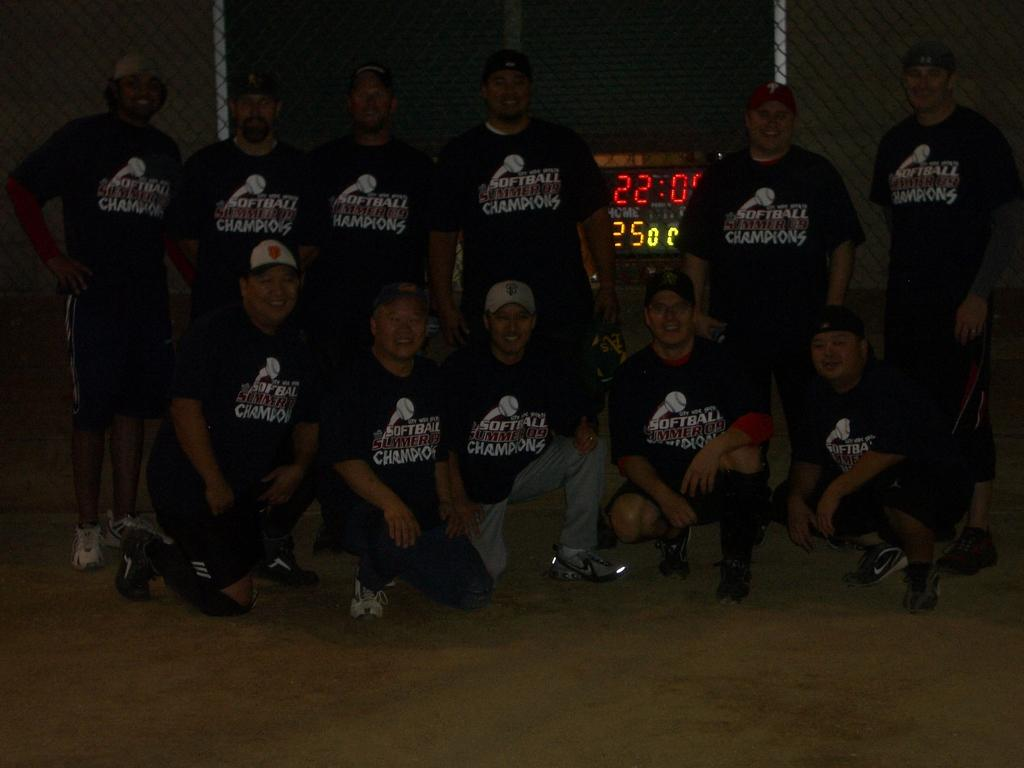<image>
Provide a brief description of the given image. A group of men with a words soft ball summer champions on their jerseys. 